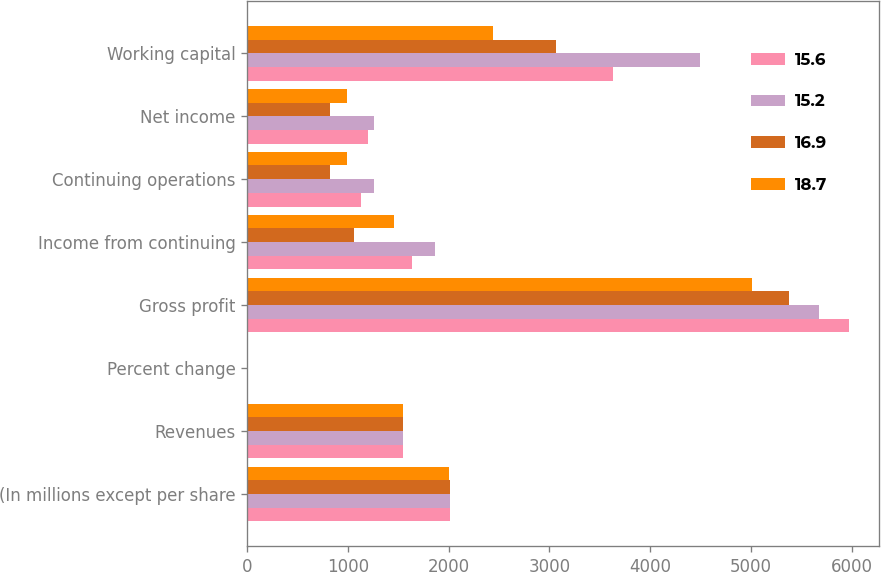Convert chart. <chart><loc_0><loc_0><loc_500><loc_500><stacked_bar_chart><ecel><fcel>(In millions except per share<fcel>Revenues<fcel>Percent change<fcel>Gross profit<fcel>Income from continuing<fcel>Continuing operations<fcel>Net income<fcel>Working capital<nl><fcel>15.6<fcel>2011<fcel>1546<fcel>3.1<fcel>5970<fcel>1635<fcel>1130<fcel>1202<fcel>3631<nl><fcel>15.2<fcel>2010<fcel>1546<fcel>1.9<fcel>5676<fcel>1864<fcel>1263<fcel>1263<fcel>4492<nl><fcel>16.9<fcel>2009<fcel>1546<fcel>4.8<fcel>5378<fcel>1064<fcel>823<fcel>823<fcel>3065<nl><fcel>18.7<fcel>2008<fcel>1546<fcel>9.4<fcel>5009<fcel>1457<fcel>989<fcel>990<fcel>2438<nl></chart> 